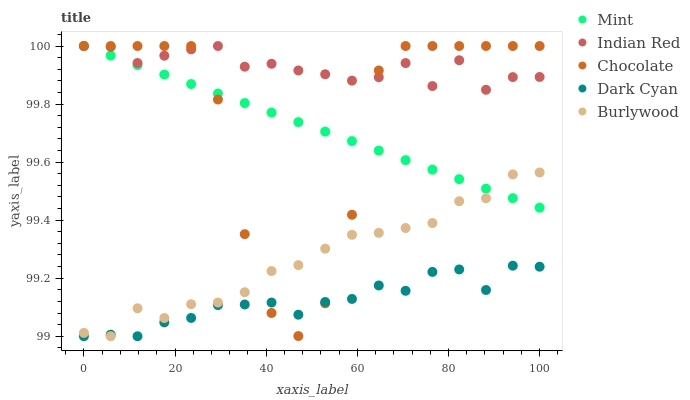Does Dark Cyan have the minimum area under the curve?
Answer yes or no. Yes. Does Indian Red have the maximum area under the curve?
Answer yes or no. Yes. Does Burlywood have the minimum area under the curve?
Answer yes or no. No. Does Burlywood have the maximum area under the curve?
Answer yes or no. No. Is Mint the smoothest?
Answer yes or no. Yes. Is Chocolate the roughest?
Answer yes or no. Yes. Is Burlywood the smoothest?
Answer yes or no. No. Is Burlywood the roughest?
Answer yes or no. No. Does Dark Cyan have the lowest value?
Answer yes or no. Yes. Does Mint have the lowest value?
Answer yes or no. No. Does Chocolate have the highest value?
Answer yes or no. Yes. Does Burlywood have the highest value?
Answer yes or no. No. Is Dark Cyan less than Indian Red?
Answer yes or no. Yes. Is Mint greater than Dark Cyan?
Answer yes or no. Yes. Does Chocolate intersect Indian Red?
Answer yes or no. Yes. Is Chocolate less than Indian Red?
Answer yes or no. No. Is Chocolate greater than Indian Red?
Answer yes or no. No. Does Dark Cyan intersect Indian Red?
Answer yes or no. No. 